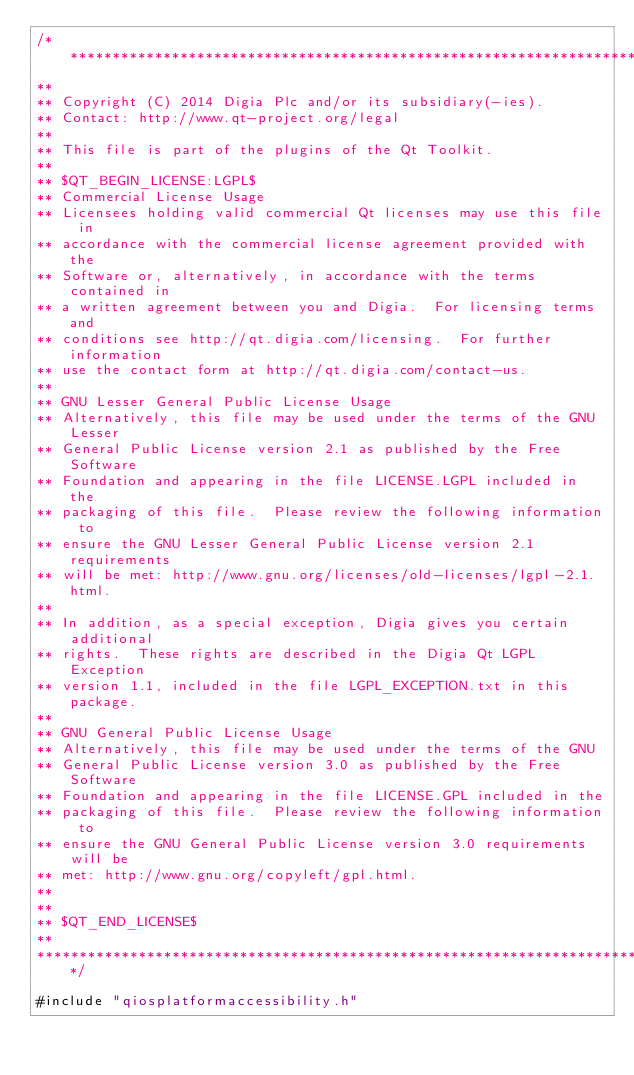<code> <loc_0><loc_0><loc_500><loc_500><_ObjectiveC_>/****************************************************************************
**
** Copyright (C) 2014 Digia Plc and/or its subsidiary(-ies).
** Contact: http://www.qt-project.org/legal
**
** This file is part of the plugins of the Qt Toolkit.
**
** $QT_BEGIN_LICENSE:LGPL$
** Commercial License Usage
** Licensees holding valid commercial Qt licenses may use this file in
** accordance with the commercial license agreement provided with the
** Software or, alternatively, in accordance with the terms contained in
** a written agreement between you and Digia.  For licensing terms and
** conditions see http://qt.digia.com/licensing.  For further information
** use the contact form at http://qt.digia.com/contact-us.
**
** GNU Lesser General Public License Usage
** Alternatively, this file may be used under the terms of the GNU Lesser
** General Public License version 2.1 as published by the Free Software
** Foundation and appearing in the file LICENSE.LGPL included in the
** packaging of this file.  Please review the following information to
** ensure the GNU Lesser General Public License version 2.1 requirements
** will be met: http://www.gnu.org/licenses/old-licenses/lgpl-2.1.html.
**
** In addition, as a special exception, Digia gives you certain additional
** rights.  These rights are described in the Digia Qt LGPL Exception
** version 1.1, included in the file LGPL_EXCEPTION.txt in this package.
**
** GNU General Public License Usage
** Alternatively, this file may be used under the terms of the GNU
** General Public License version 3.0 as published by the Free Software
** Foundation and appearing in the file LICENSE.GPL included in the
** packaging of this file.  Please review the following information to
** ensure the GNU General Public License version 3.0 requirements will be
** met: http://www.gnu.org/copyleft/gpl.html.
**
**
** $QT_END_LICENSE$
**
****************************************************************************/

#include "qiosplatformaccessibility.h"</code> 